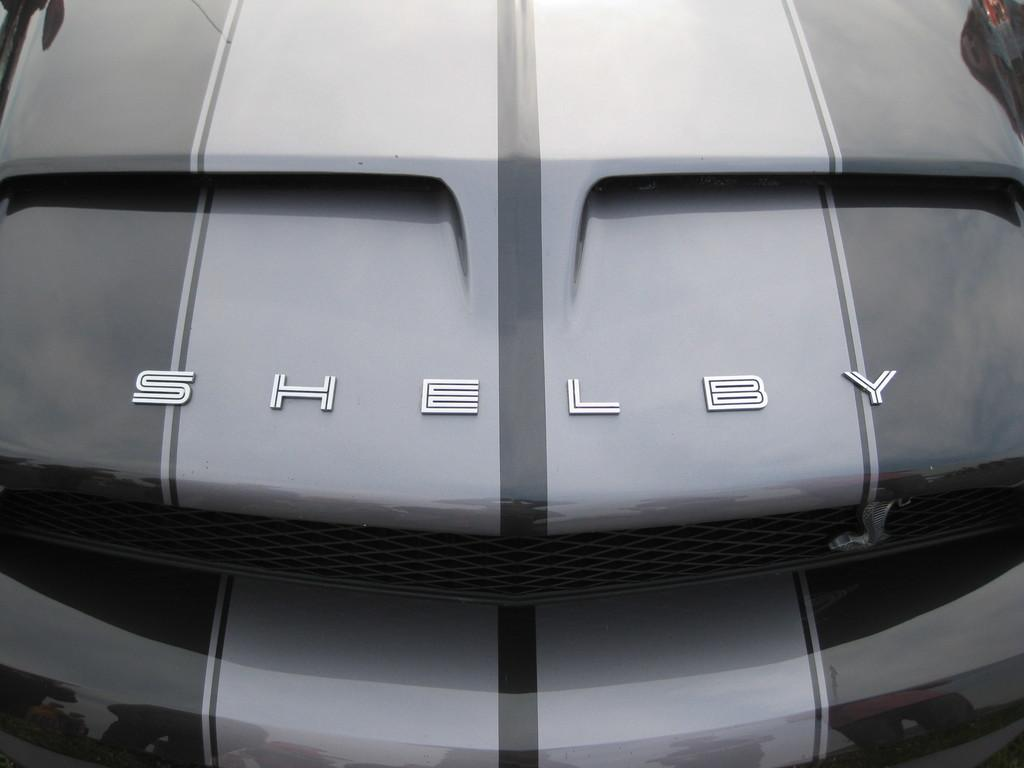What is the main subject of the image? The main subject of the image is a vehicle. Can you describe any specific features of the vehicle? Yes, the vehicle has text on it. What is the size of the caption on the vehicle in the image? There is no caption present in the image; the text on the vehicle is not a caption. 